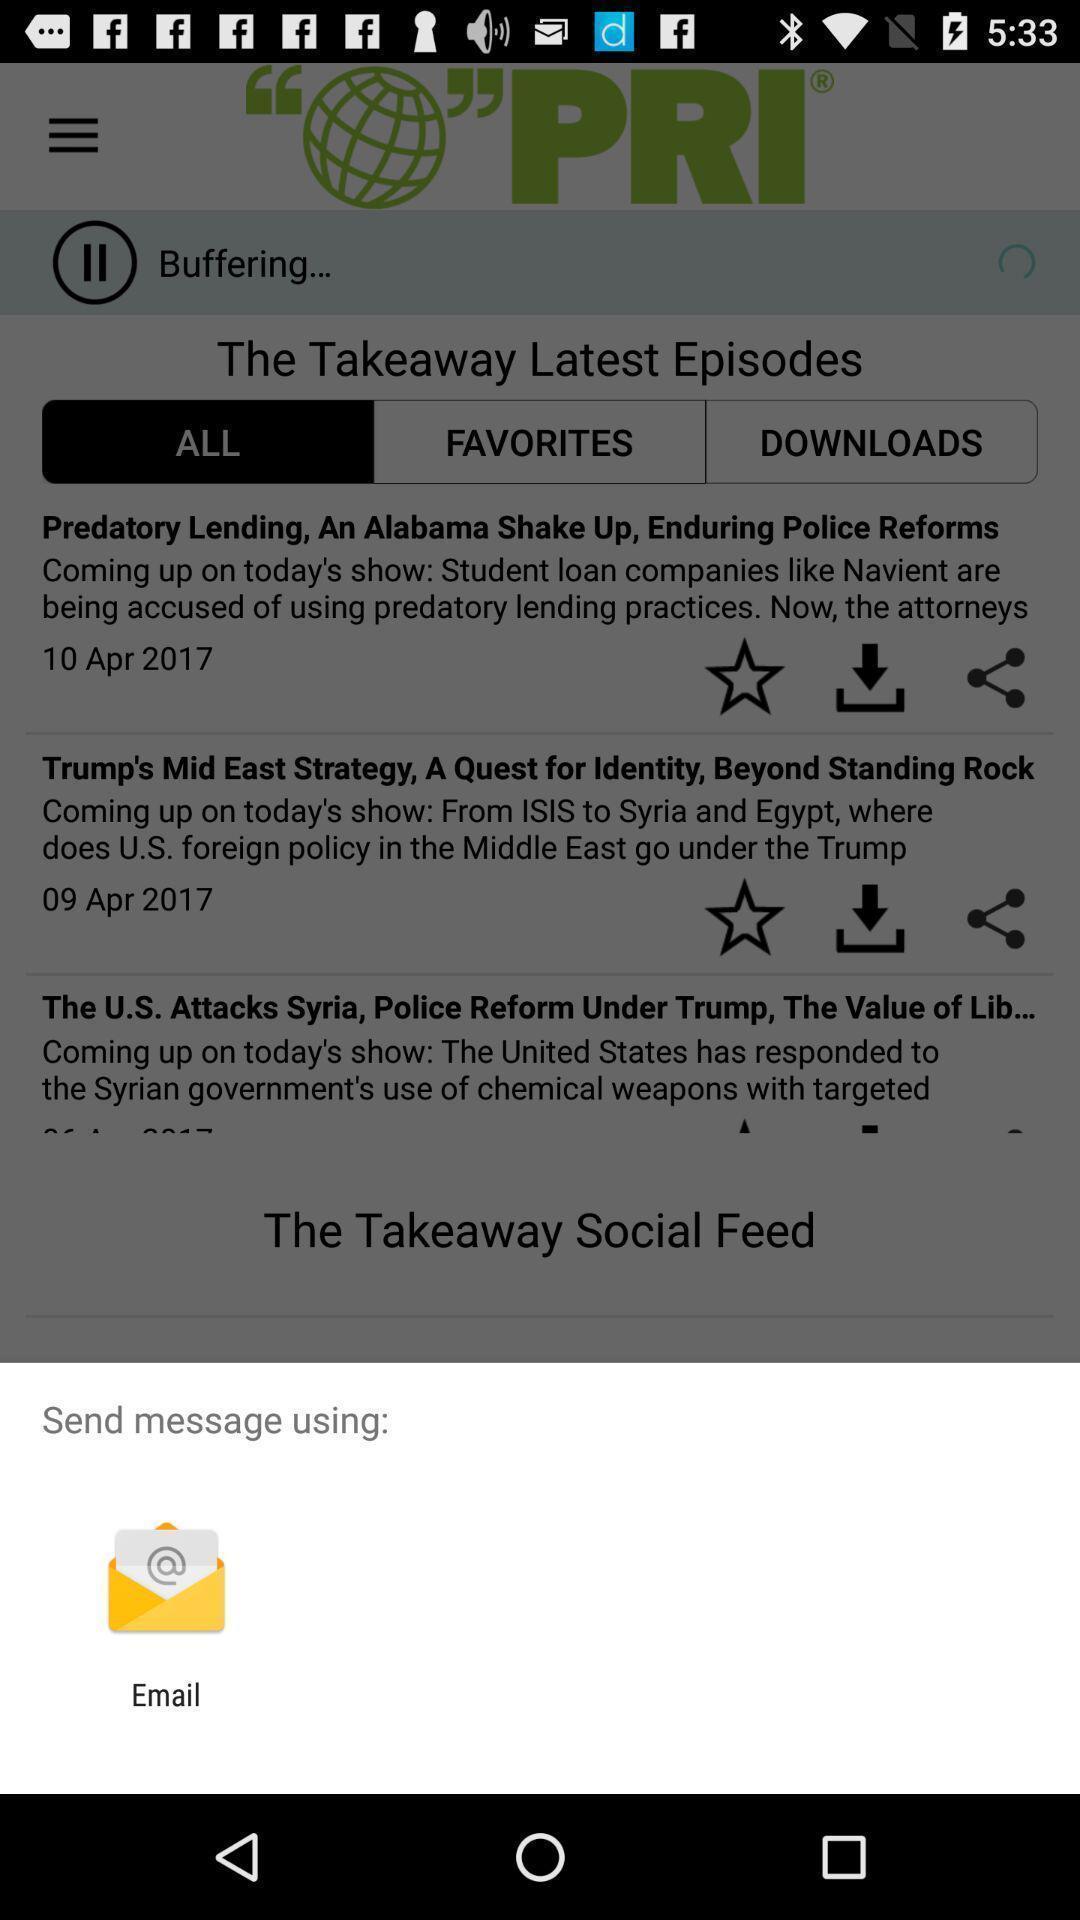Please provide a description for this image. Pop-up widget showing a data sharing app. 